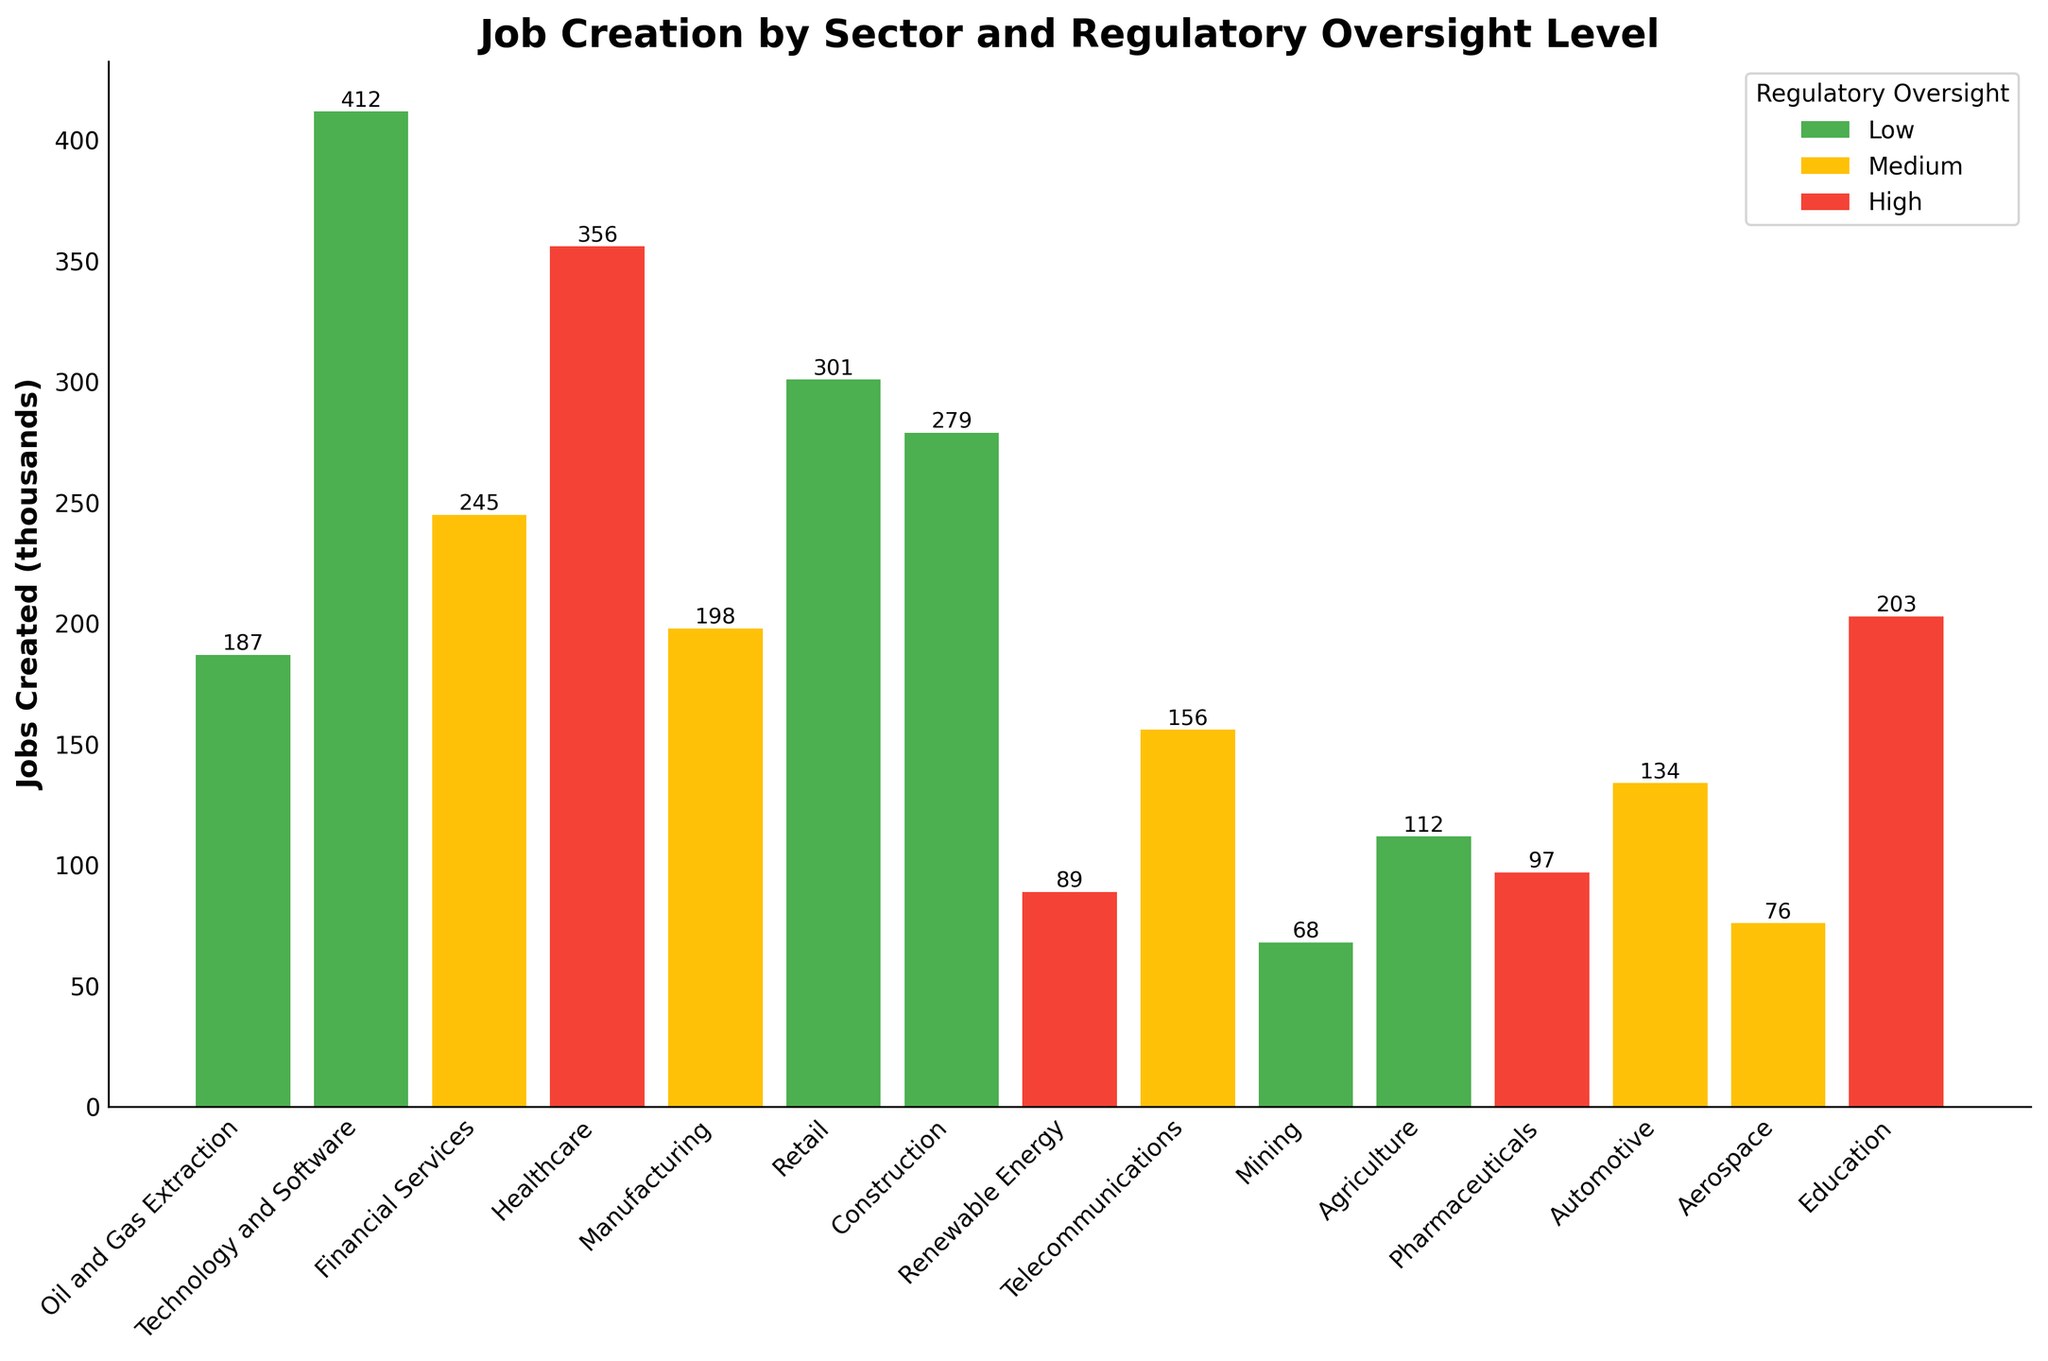Which sector has the highest job creation? The Technology and Software sector has the highest job creation, as indicated by the tallest bar in the chart, which corresponds to 412 thousand jobs created.
Answer: Technology and Software Compare the job creation between sectors with low and high regulatory oversight levels. Which level created more jobs in total? Sum the jobs created in sectors with low regulatory oversight: 187 + 412 + 301 + 279 + 68 + 112 + 156 = 1515 thousand. Then sum the jobs created in sectors with high regulatory oversight: 356 + 89 + 97 + 203 = 745 thousand. Comparing the two totals, sectors with low regulatory oversight created more jobs overall.
Answer: Low regulatory oversight What is the difference in job creation between the Healthcare and Pharmaceutical sectors? The Healthcare sector created 356 thousand jobs, and the Pharmaceutical sector created 97 thousand jobs. Subtracting these gives 356 - 97 = 259 thousand.
Answer: 259 thousand Which sector has the lowest job creation, and what is its regulatory oversight level? The Mining sector has the lowest job creation, as indicated by the shortest bar in the chart, which corresponds to 68 thousand jobs. Its regulatory oversight level is Low.
Answer: Mining, Low If you sum the jobs created in the Automotive and Aerospace sectors, how many jobs are created in total? The Automotive sector created 134 thousand jobs, and the Aerospace sector created 76 thousand jobs. Summing these gives 134 + 76 = 210 thousand jobs.
Answer: 210 thousand Is there a sector with the same number of jobs created as the Telecommunications sector? If so, name it. The Telecommunications sector created 156 thousand jobs. Scanning the chart, no other sector created exactly 156 thousand jobs, so there is no sector with the same number of jobs created.
Answer: No How do job creation rates compare between sectors with medium regulatory oversight? The sectors with medium regulatory oversight are: Financial Services (245 thousand), Manufacturing (198 thousand), Telecommunications (156 thousand), Automotive (134 thousand), and Aerospace (76 thousand). Comparing their rates, Financial Services created the most jobs (245 thousand), and Aerospace created the fewest (76 thousand).
Answer: Financial Services leads, Aerospace lags Are there more jobs created in technology-related sectors (Technology and Software + Telecommunications) than in construction-related sectors (Construction + Manufacturing)? For technology-related sectors: Technology and Software created 412 thousand jobs and Telecommunications created 156 thousand jobs. Summing these gives 412 + 156 = 568 thousand jobs. For construction-related sectors: Construction created 279 thousand jobs and Manufacturing created 198 thousand jobs. Summing these gives 279 + 198 = 477 thousand jobs. Comparing the totals, technology-related sectors created more jobs.
Answer: Yes, technology-related What's the average job creation in sectors with high regulatory oversight? The sectors with high regulatory oversight are Healthcare (356 thousand), Renewable Energy (89 thousand), Pharmaceuticals (97 thousand), and Education (203 thousand). Summing these gives 356 + 89 + 97 + 203 = 745 thousand. The number of sectors is 4. Calculating the average: 745 / 4 = 186.25 thousand jobs on average.
Answer: 186.25 thousand 